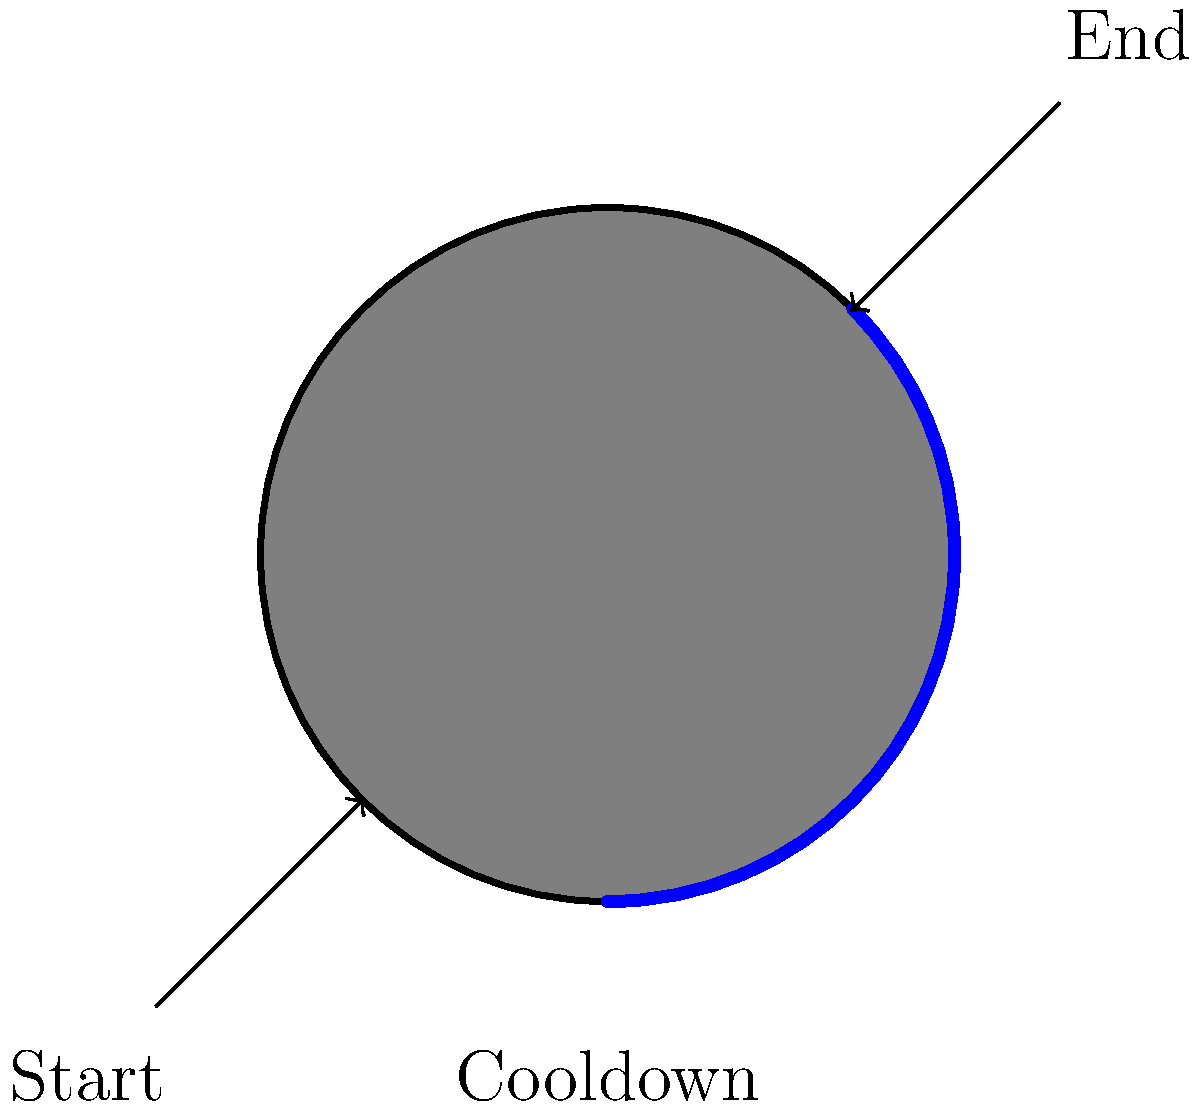In animating a skill cooldown indicator for a MOBA-style game, which technique would be most efficient for creating a smooth, circular cooldown animation as shown in the diagram? To create a smooth, circular cooldown animation for a MOBA-style game, we should consider the following steps:

1. Start with a full circle representing the skill icon.
2. Use a mask or overlay to reveal/hide portions of the circle.
3. Animate the mask/overlay rotation to show the cooldown progress.

The most efficient technique for this animation would be:

1. Create a circular mask that covers the entire skill icon.
2. Use a radial wipe effect on the mask.
3. Animate the angle of the radial wipe from 0° to 360° over the cooldown duration.

This method is efficient because:
a) It requires minimal computational resources.
b) It can be easily implemented using most game engines or UI frameworks.
c) It provides smooth animation without the need for frame-by-frame updates.

The radial wipe can be achieved by:
1. Using a shader to calculate the reveal angle based on time.
2. Utilizing built-in UI components that support radial progress indicators.

By using this technique, we ensure that the cooldown animation is visually appealing and performance-friendly, which is crucial for MOBA games where multiple skills and effects need to be displayed simultaneously.
Answer: Radial wipe animation 